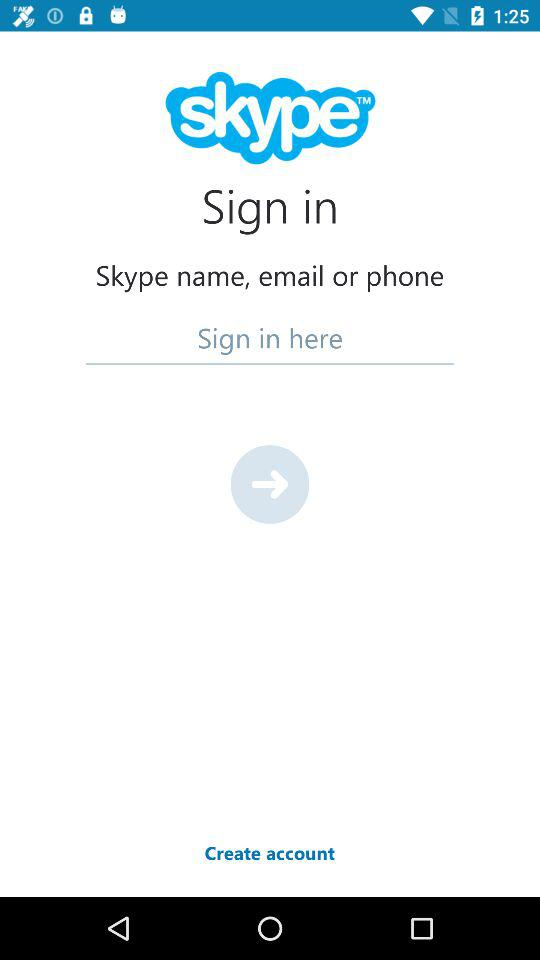Which are the options we can use to sign in? The options you can use to sign in are "Skype name", "email" and "phone". 